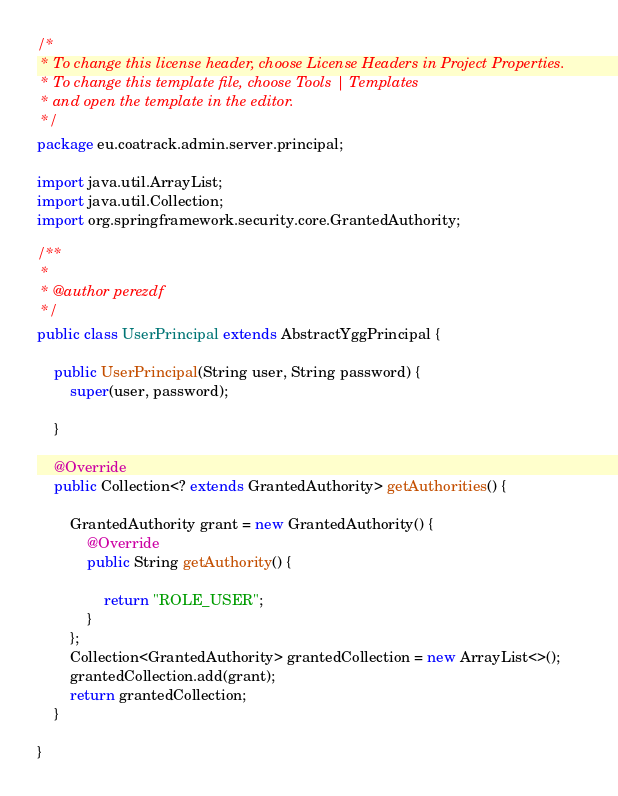Convert code to text. <code><loc_0><loc_0><loc_500><loc_500><_Java_>/*
 * To change this license header, choose License Headers in Project Properties.
 * To change this template file, choose Tools | Templates
 * and open the template in the editor.
 */
package eu.coatrack.admin.server.principal;

import java.util.ArrayList;
import java.util.Collection;
import org.springframework.security.core.GrantedAuthority;

/**
 *
 * @author perezdf
 */
public class UserPrincipal extends AbstractYggPrincipal {

    public UserPrincipal(String user, String password) {
        super(user, password);

    }

    @Override
    public Collection<? extends GrantedAuthority> getAuthorities() {

        GrantedAuthority grant = new GrantedAuthority() {
            @Override
            public String getAuthority() {

                return "ROLE_USER";
            }
        };
        Collection<GrantedAuthority> grantedCollection = new ArrayList<>();
        grantedCollection.add(grant);
        return grantedCollection;
    }

}
</code> 